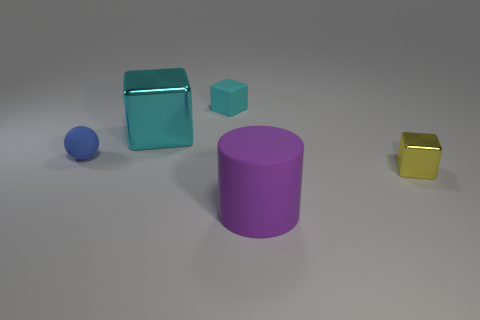Add 1 big blue shiny objects. How many objects exist? 6 Subtract all cylinders. How many objects are left? 4 Subtract 0 purple blocks. How many objects are left? 5 Subtract all tiny cubes. Subtract all green things. How many objects are left? 3 Add 5 small rubber spheres. How many small rubber spheres are left? 6 Add 4 tiny brown balls. How many tiny brown balls exist? 4 